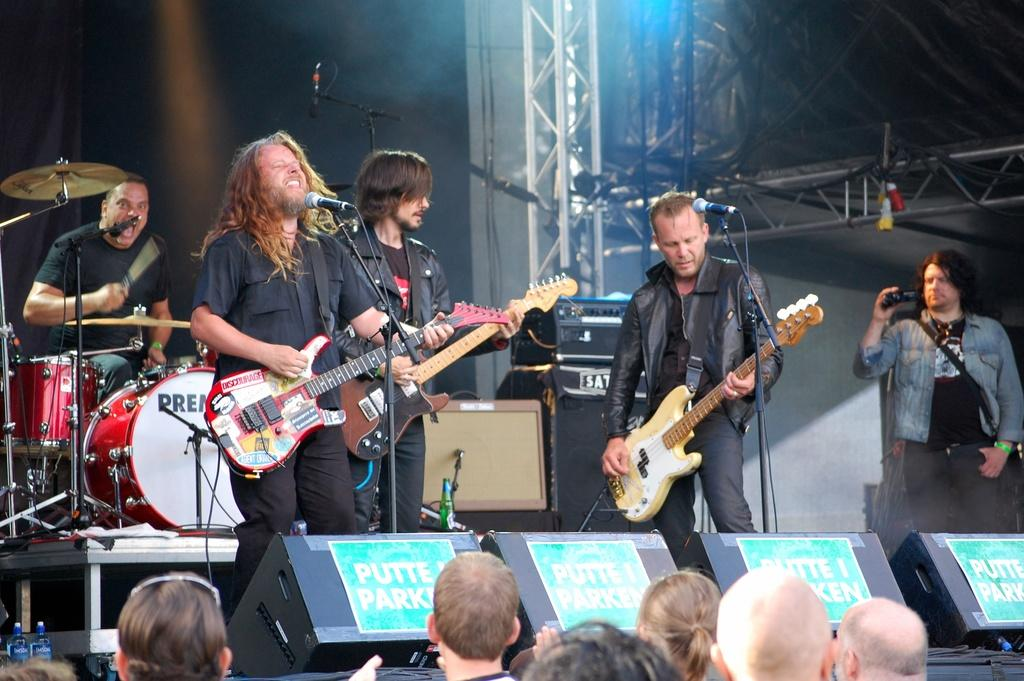What is happening on the stage in the image? There are people on a stage, and they are performing. What type of performance is taking place on the stage? The performance involves playing musical instruments. Are there any spectators in the image? Yes, there are people in front of the stage. What is the weather like during the performance in the image? The provided facts do not mention the weather, so we cannot determine the weather conditions during the performance. 